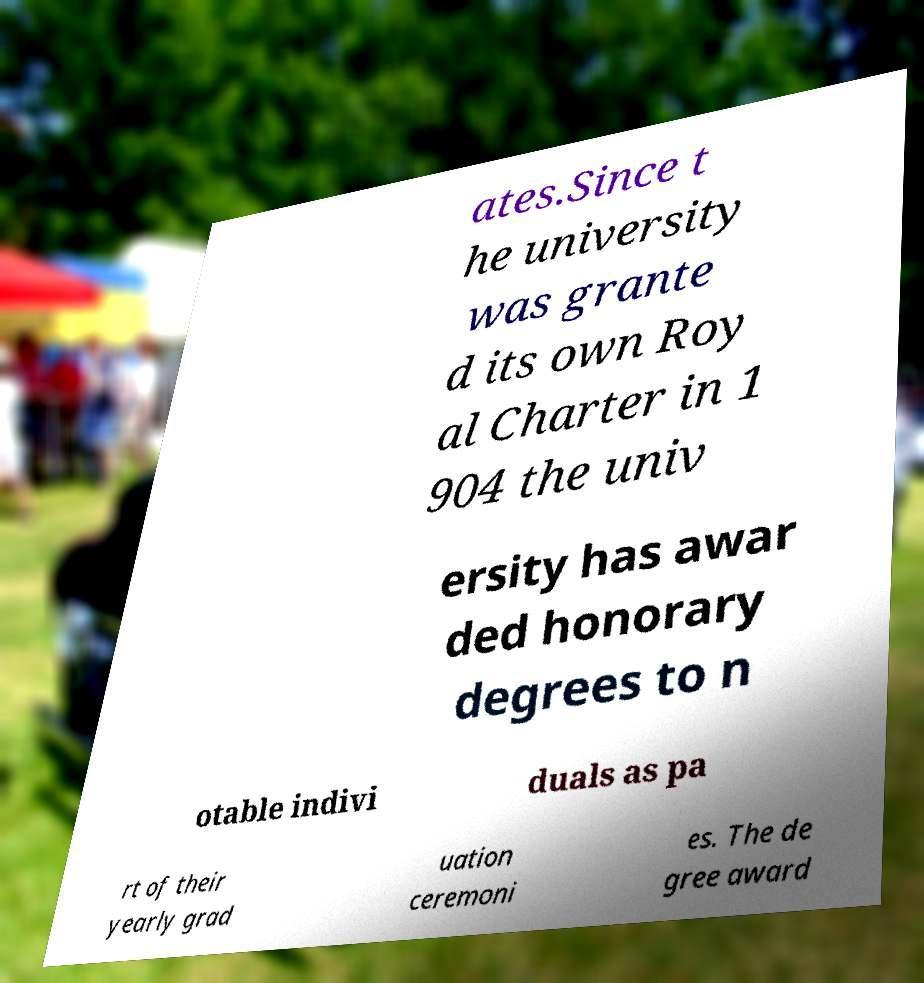Could you assist in decoding the text presented in this image and type it out clearly? ates.Since t he university was grante d its own Roy al Charter in 1 904 the univ ersity has awar ded honorary degrees to n otable indivi duals as pa rt of their yearly grad uation ceremoni es. The de gree award 